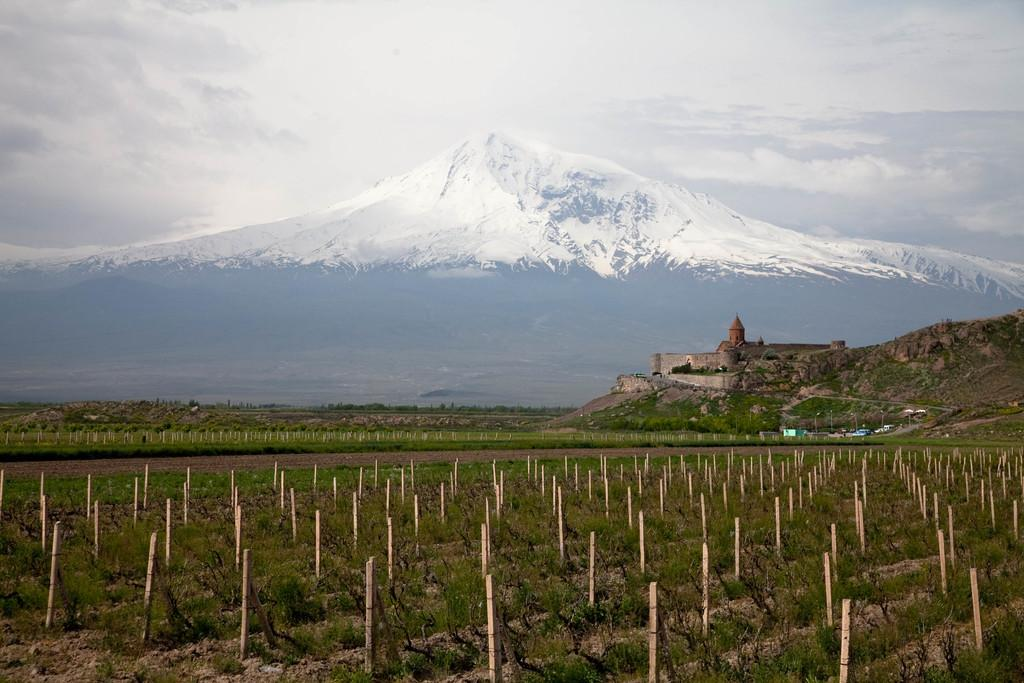What is located in the field in the image? There is a wooden pole in a field in the image. What can be seen in the background of the image? There is a mountain in the background, and there is a temple on the mountain. Are there any other mountains visible in the image? Yes, there is another mountain covered with snow in the image. Is there a gate made of quicksand in the image? No, there is no gate made of quicksand in the image. Can you see a shop on the mountain in the image? No, there is no shop visible on the mountain in the image. 